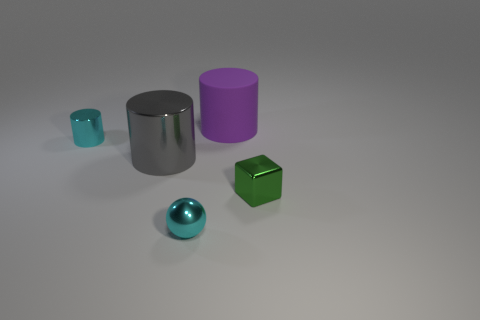What is the small object that is in front of the tiny metallic block made of?
Give a very brief answer. Metal. What size is the gray thing that is the same shape as the large purple matte thing?
Make the answer very short. Large. Are there fewer blocks that are to the left of the big purple cylinder than big metal cylinders?
Your answer should be compact. Yes. Are any matte cylinders visible?
Provide a succinct answer. Yes. The large matte object that is the same shape as the large shiny thing is what color?
Ensure brevity in your answer.  Purple. There is a thing to the left of the big shiny cylinder; does it have the same color as the shiny ball?
Provide a short and direct response. Yes. Is the matte thing the same size as the gray thing?
Your answer should be compact. Yes. What is the shape of the green object that is made of the same material as the large gray object?
Provide a succinct answer. Cube. How many other objects are there of the same shape as the green object?
Your answer should be compact. 0. There is a cyan object that is on the right side of the tiny cyan thing that is behind the small green shiny cube that is in front of the rubber cylinder; what is its shape?
Give a very brief answer. Sphere. 